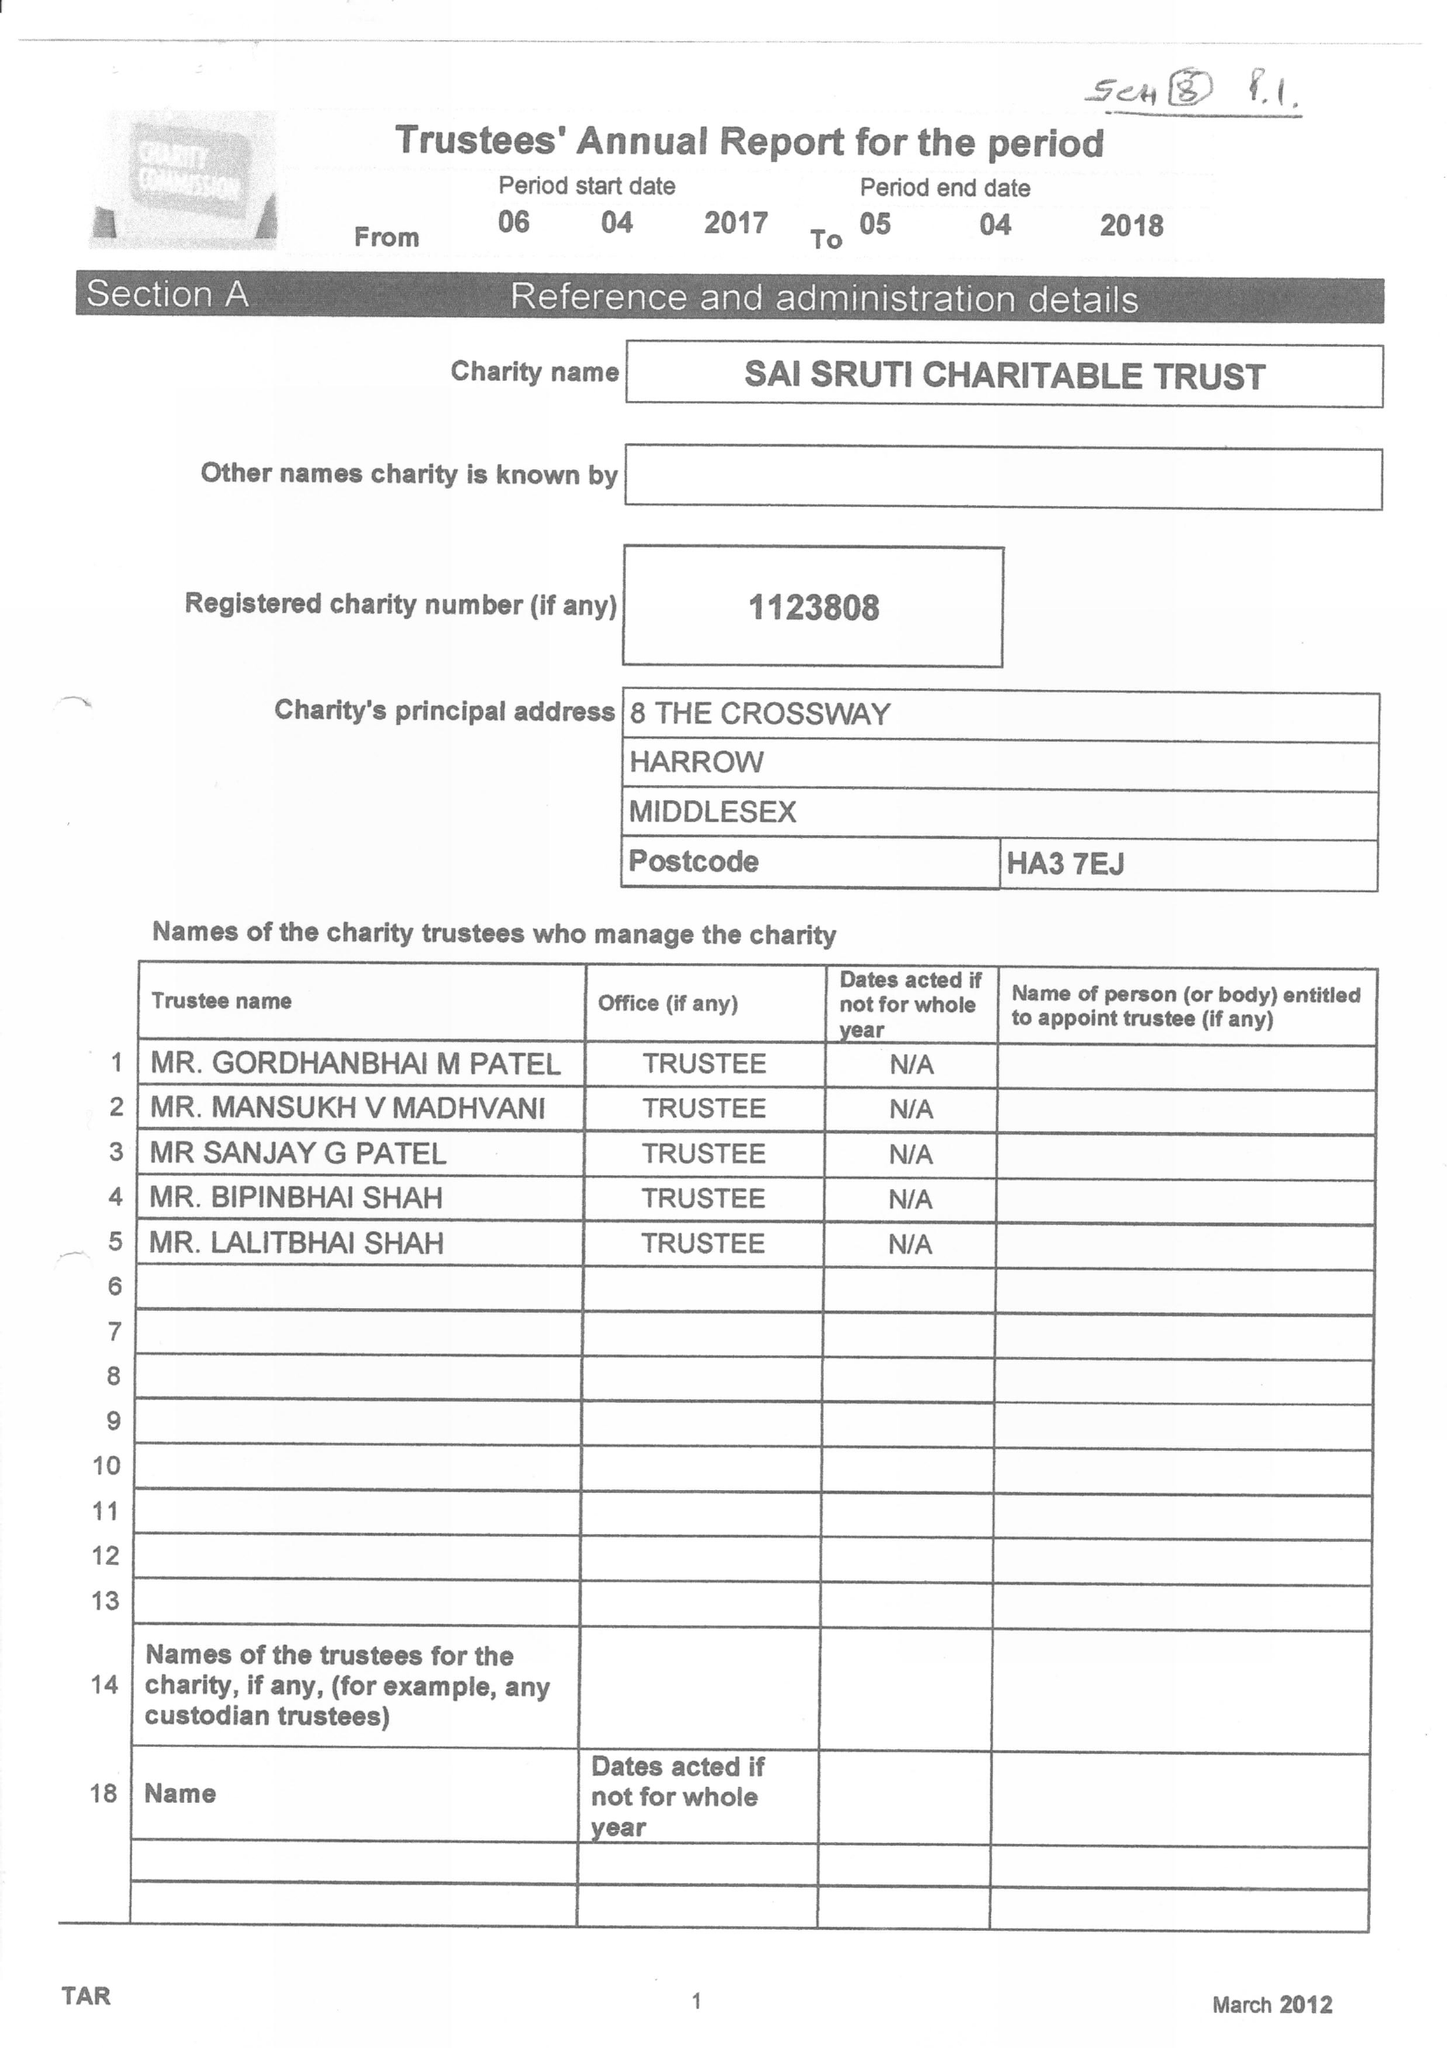What is the value for the spending_annually_in_british_pounds?
Answer the question using a single word or phrase. 96607.00 